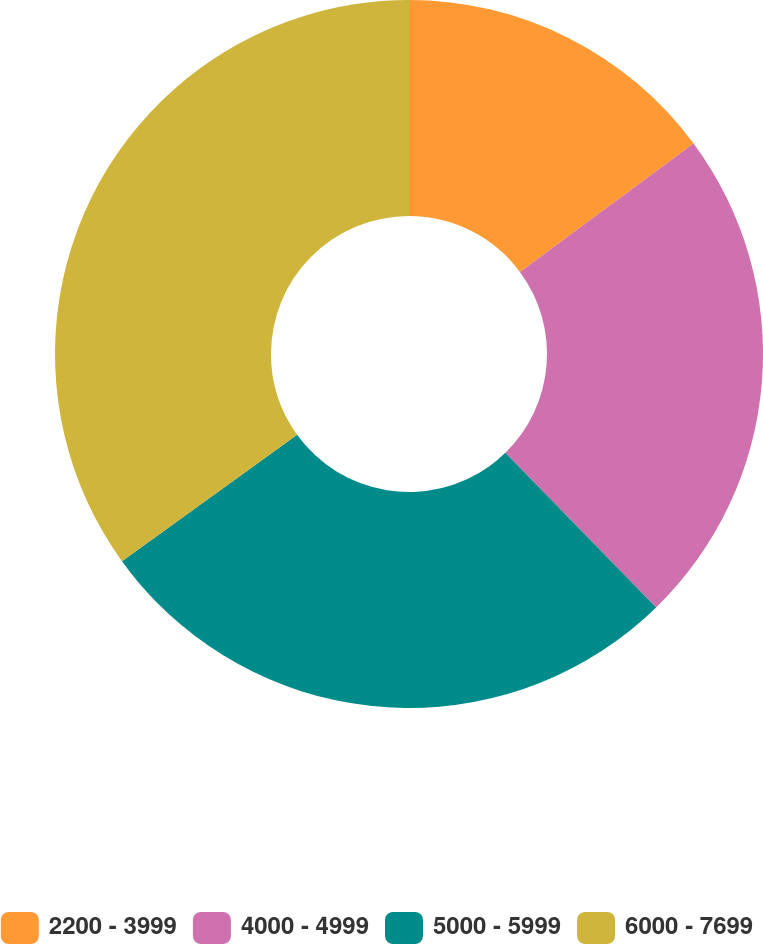<chart> <loc_0><loc_0><loc_500><loc_500><pie_chart><fcel>2200 - 3999<fcel>4000 - 4999<fcel>5000 - 5999<fcel>6000 - 7699<nl><fcel>14.86%<fcel>22.84%<fcel>27.35%<fcel>34.95%<nl></chart> 